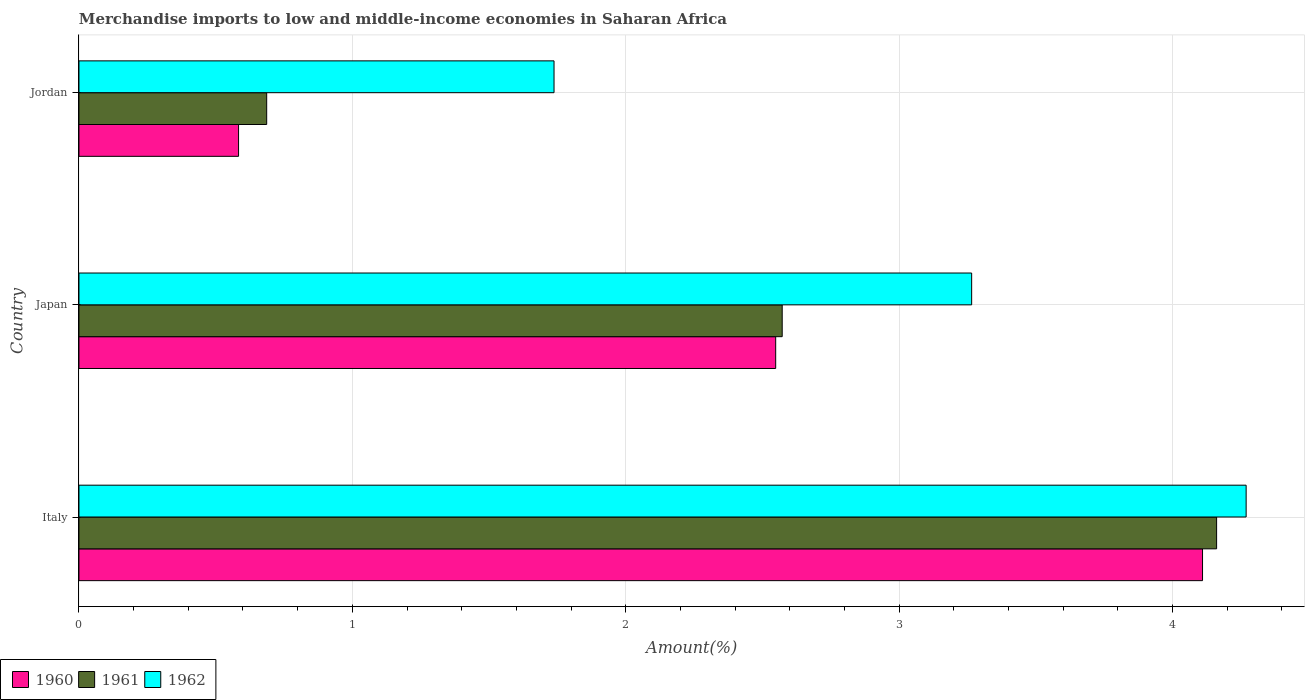How many different coloured bars are there?
Give a very brief answer. 3. How many bars are there on the 1st tick from the top?
Provide a succinct answer. 3. In how many cases, is the number of bars for a given country not equal to the number of legend labels?
Ensure brevity in your answer.  0. What is the percentage of amount earned from merchandise imports in 1960 in Italy?
Offer a terse response. 4.11. Across all countries, what is the maximum percentage of amount earned from merchandise imports in 1962?
Ensure brevity in your answer.  4.27. Across all countries, what is the minimum percentage of amount earned from merchandise imports in 1962?
Offer a terse response. 1.74. In which country was the percentage of amount earned from merchandise imports in 1962 maximum?
Provide a succinct answer. Italy. In which country was the percentage of amount earned from merchandise imports in 1962 minimum?
Offer a very short reply. Jordan. What is the total percentage of amount earned from merchandise imports in 1961 in the graph?
Provide a succinct answer. 7.42. What is the difference between the percentage of amount earned from merchandise imports in 1960 in Italy and that in Japan?
Your response must be concise. 1.56. What is the difference between the percentage of amount earned from merchandise imports in 1960 in Jordan and the percentage of amount earned from merchandise imports in 1961 in Japan?
Your answer should be very brief. -1.99. What is the average percentage of amount earned from merchandise imports in 1962 per country?
Keep it short and to the point. 3.09. What is the difference between the percentage of amount earned from merchandise imports in 1960 and percentage of amount earned from merchandise imports in 1961 in Jordan?
Offer a very short reply. -0.1. In how many countries, is the percentage of amount earned from merchandise imports in 1961 greater than 1.8 %?
Your response must be concise. 2. What is the ratio of the percentage of amount earned from merchandise imports in 1962 in Japan to that in Jordan?
Your response must be concise. 1.88. Is the percentage of amount earned from merchandise imports in 1960 in Italy less than that in Japan?
Ensure brevity in your answer.  No. Is the difference between the percentage of amount earned from merchandise imports in 1960 in Italy and Jordan greater than the difference between the percentage of amount earned from merchandise imports in 1961 in Italy and Jordan?
Keep it short and to the point. Yes. What is the difference between the highest and the second highest percentage of amount earned from merchandise imports in 1960?
Your answer should be very brief. 1.56. What is the difference between the highest and the lowest percentage of amount earned from merchandise imports in 1961?
Keep it short and to the point. 3.47. What does the 3rd bar from the bottom in Japan represents?
Your response must be concise. 1962. Is it the case that in every country, the sum of the percentage of amount earned from merchandise imports in 1962 and percentage of amount earned from merchandise imports in 1960 is greater than the percentage of amount earned from merchandise imports in 1961?
Provide a short and direct response. Yes. How many bars are there?
Your response must be concise. 9. What is the difference between two consecutive major ticks on the X-axis?
Offer a terse response. 1. Does the graph contain any zero values?
Keep it short and to the point. No. Does the graph contain grids?
Your response must be concise. Yes. Where does the legend appear in the graph?
Offer a terse response. Bottom left. What is the title of the graph?
Provide a short and direct response. Merchandise imports to low and middle-income economies in Saharan Africa. What is the label or title of the X-axis?
Your answer should be very brief. Amount(%). What is the Amount(%) of 1960 in Italy?
Your response must be concise. 4.11. What is the Amount(%) in 1961 in Italy?
Give a very brief answer. 4.16. What is the Amount(%) of 1962 in Italy?
Offer a very short reply. 4.27. What is the Amount(%) in 1960 in Japan?
Your answer should be compact. 2.55. What is the Amount(%) in 1961 in Japan?
Provide a succinct answer. 2.57. What is the Amount(%) of 1962 in Japan?
Provide a succinct answer. 3.27. What is the Amount(%) in 1960 in Jordan?
Your answer should be very brief. 0.58. What is the Amount(%) of 1961 in Jordan?
Ensure brevity in your answer.  0.69. What is the Amount(%) in 1962 in Jordan?
Ensure brevity in your answer.  1.74. Across all countries, what is the maximum Amount(%) of 1960?
Give a very brief answer. 4.11. Across all countries, what is the maximum Amount(%) of 1961?
Your answer should be compact. 4.16. Across all countries, what is the maximum Amount(%) in 1962?
Your answer should be very brief. 4.27. Across all countries, what is the minimum Amount(%) in 1960?
Your answer should be compact. 0.58. Across all countries, what is the minimum Amount(%) in 1961?
Your answer should be compact. 0.69. Across all countries, what is the minimum Amount(%) in 1962?
Give a very brief answer. 1.74. What is the total Amount(%) of 1960 in the graph?
Make the answer very short. 7.24. What is the total Amount(%) in 1961 in the graph?
Offer a terse response. 7.42. What is the total Amount(%) of 1962 in the graph?
Provide a succinct answer. 9.27. What is the difference between the Amount(%) of 1960 in Italy and that in Japan?
Provide a short and direct response. 1.56. What is the difference between the Amount(%) in 1961 in Italy and that in Japan?
Your answer should be very brief. 1.59. What is the difference between the Amount(%) of 1960 in Italy and that in Jordan?
Your answer should be compact. 3.53. What is the difference between the Amount(%) in 1961 in Italy and that in Jordan?
Your answer should be compact. 3.47. What is the difference between the Amount(%) in 1962 in Italy and that in Jordan?
Your answer should be compact. 2.53. What is the difference between the Amount(%) of 1960 in Japan and that in Jordan?
Provide a succinct answer. 1.96. What is the difference between the Amount(%) in 1961 in Japan and that in Jordan?
Your answer should be very brief. 1.89. What is the difference between the Amount(%) of 1962 in Japan and that in Jordan?
Make the answer very short. 1.53. What is the difference between the Amount(%) of 1960 in Italy and the Amount(%) of 1961 in Japan?
Your answer should be very brief. 1.54. What is the difference between the Amount(%) in 1960 in Italy and the Amount(%) in 1962 in Japan?
Your response must be concise. 0.84. What is the difference between the Amount(%) in 1961 in Italy and the Amount(%) in 1962 in Japan?
Ensure brevity in your answer.  0.9. What is the difference between the Amount(%) in 1960 in Italy and the Amount(%) in 1961 in Jordan?
Offer a very short reply. 3.42. What is the difference between the Amount(%) in 1960 in Italy and the Amount(%) in 1962 in Jordan?
Ensure brevity in your answer.  2.37. What is the difference between the Amount(%) in 1961 in Italy and the Amount(%) in 1962 in Jordan?
Ensure brevity in your answer.  2.42. What is the difference between the Amount(%) in 1960 in Japan and the Amount(%) in 1961 in Jordan?
Keep it short and to the point. 1.86. What is the difference between the Amount(%) in 1960 in Japan and the Amount(%) in 1962 in Jordan?
Ensure brevity in your answer.  0.81. What is the difference between the Amount(%) of 1961 in Japan and the Amount(%) of 1962 in Jordan?
Provide a succinct answer. 0.83. What is the average Amount(%) in 1960 per country?
Offer a very short reply. 2.41. What is the average Amount(%) in 1961 per country?
Ensure brevity in your answer.  2.47. What is the average Amount(%) of 1962 per country?
Offer a very short reply. 3.09. What is the difference between the Amount(%) of 1960 and Amount(%) of 1961 in Italy?
Provide a short and direct response. -0.05. What is the difference between the Amount(%) in 1960 and Amount(%) in 1962 in Italy?
Keep it short and to the point. -0.16. What is the difference between the Amount(%) in 1961 and Amount(%) in 1962 in Italy?
Keep it short and to the point. -0.11. What is the difference between the Amount(%) of 1960 and Amount(%) of 1961 in Japan?
Your answer should be very brief. -0.02. What is the difference between the Amount(%) in 1960 and Amount(%) in 1962 in Japan?
Make the answer very short. -0.72. What is the difference between the Amount(%) of 1961 and Amount(%) of 1962 in Japan?
Provide a succinct answer. -0.69. What is the difference between the Amount(%) of 1960 and Amount(%) of 1961 in Jordan?
Offer a terse response. -0.1. What is the difference between the Amount(%) in 1960 and Amount(%) in 1962 in Jordan?
Provide a short and direct response. -1.15. What is the difference between the Amount(%) of 1961 and Amount(%) of 1962 in Jordan?
Make the answer very short. -1.05. What is the ratio of the Amount(%) in 1960 in Italy to that in Japan?
Make the answer very short. 1.61. What is the ratio of the Amount(%) of 1961 in Italy to that in Japan?
Offer a terse response. 1.62. What is the ratio of the Amount(%) in 1962 in Italy to that in Japan?
Offer a terse response. 1.31. What is the ratio of the Amount(%) of 1960 in Italy to that in Jordan?
Keep it short and to the point. 7.04. What is the ratio of the Amount(%) in 1961 in Italy to that in Jordan?
Your answer should be compact. 6.06. What is the ratio of the Amount(%) of 1962 in Italy to that in Jordan?
Provide a short and direct response. 2.46. What is the ratio of the Amount(%) of 1960 in Japan to that in Jordan?
Make the answer very short. 4.37. What is the ratio of the Amount(%) of 1961 in Japan to that in Jordan?
Make the answer very short. 3.75. What is the ratio of the Amount(%) of 1962 in Japan to that in Jordan?
Give a very brief answer. 1.88. What is the difference between the highest and the second highest Amount(%) of 1960?
Your response must be concise. 1.56. What is the difference between the highest and the second highest Amount(%) in 1961?
Your response must be concise. 1.59. What is the difference between the highest and the second highest Amount(%) of 1962?
Provide a succinct answer. 1. What is the difference between the highest and the lowest Amount(%) in 1960?
Your response must be concise. 3.53. What is the difference between the highest and the lowest Amount(%) in 1961?
Offer a terse response. 3.47. What is the difference between the highest and the lowest Amount(%) in 1962?
Ensure brevity in your answer.  2.53. 